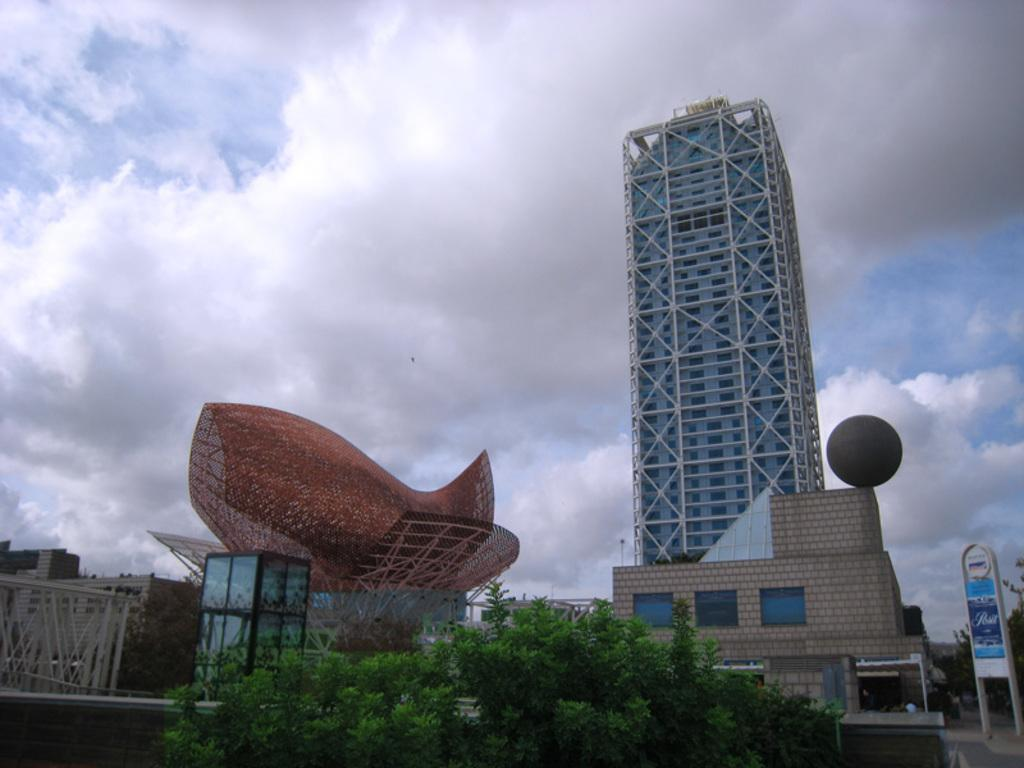What types of structures can be seen in the image? There are buildings with different shapes in the image. What other elements are present in the image besides the buildings? There are trees in the image. How would you describe the sky in the image? The sky is cloudy in the image. What type of iron can be seen in the image? There is no iron present in the image. How many quivers are visible in the image? There are no quivers present in the image. 